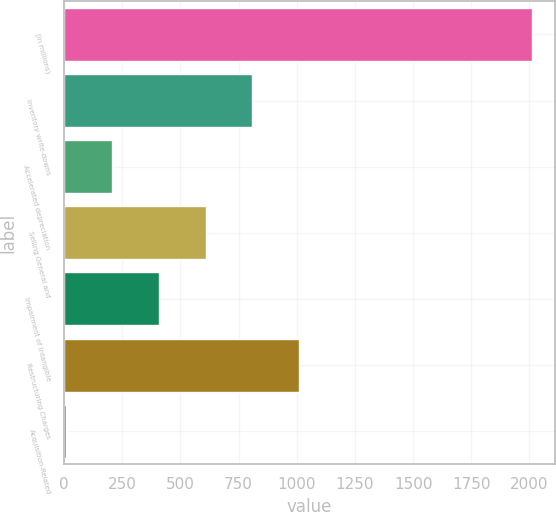Convert chart. <chart><loc_0><loc_0><loc_500><loc_500><bar_chart><fcel>(in millions)<fcel>Inventory write-downs<fcel>Accelerated depreciation<fcel>Selling General and<fcel>Impairment of Intangible<fcel>Restructuring Charges<fcel>Acquisition-Related<nl><fcel>2009<fcel>808.52<fcel>208.28<fcel>608.44<fcel>408.36<fcel>1008.6<fcel>8.2<nl></chart> 